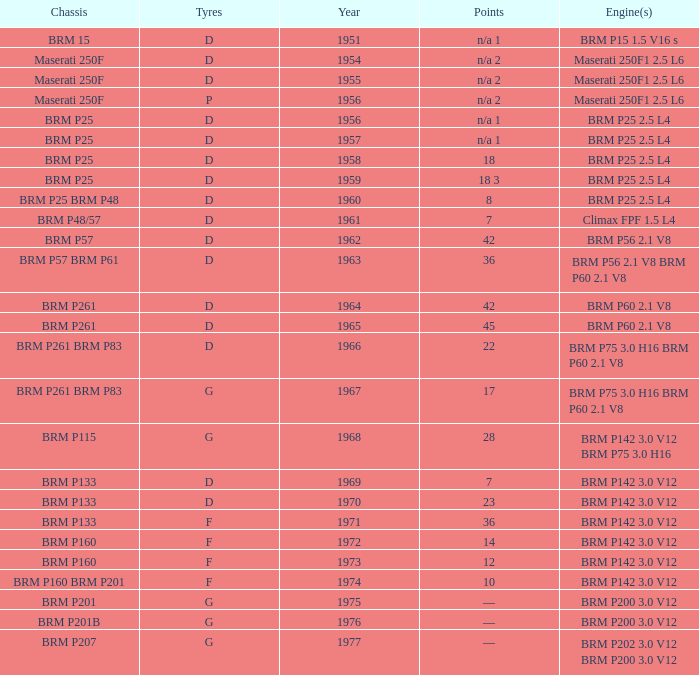Name the point for 1974 10.0. 